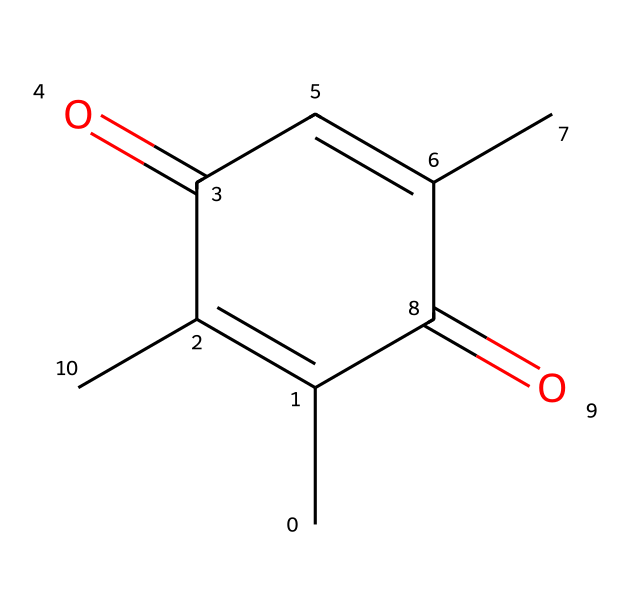What is the total number of carbon atoms in safranal? By analyzing the SMILES representation, we can count the carbon atoms denoted by "C". The structure contains 9 carbon atoms in total.
Answer: 9 How many double bonds are present in the structure of safranal? Observing the SMILES, we notice that there are 3 instances of "C=C", indicating 3 double bonds in the structure.
Answer: 3 Does safranal contain any functional groups? The presence of "C(=O)" shows that there are carbonyl functional groups (aldehyde and ketone) in safranal's structure, qualifying it as a compound with functional groups.
Answer: Yes What is the oxidation state of the central carbon in the carbonyl group? In the carbonyl functional groups (C=O), the carbon atom typically has an oxidation state of +2 because it is bonded to an oxygen atom doubly and at least one other carbon atom.
Answer: +2 How does the presence of the carbonyl groups affect the smell of safranal? The carbonyl groups in safranal contribute to its aromatic characteristics and are key to the compound’s distinct smell, making it recognizable in flavors and fragrances.
Answer: Aromatic What type of chemical compound is safranal classified as? Safranal is classified as a terpenoid due to its structure being derived from a terpene precursor, which often contributes to its flavor and fragrance properties.
Answer: Terpenoid 